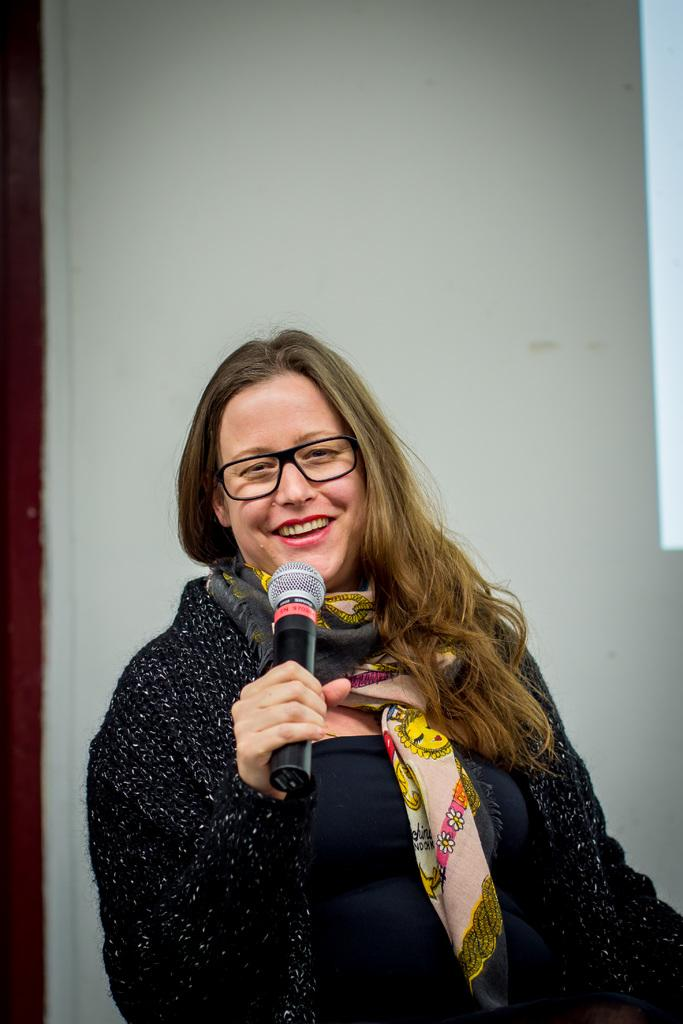What is the main subject of the image? There is a person in the image. What is the person doing in the image? The person is standing and holding a microphone. What can be seen in the background of the image? There is a wall in the background of the image. What type of punishment is the person receiving in the image? There is no indication of punishment in the image; the person is simply standing and holding a microphone. What kind of animal can be seen interacting with the person in the image? There are no animals present in the image. 